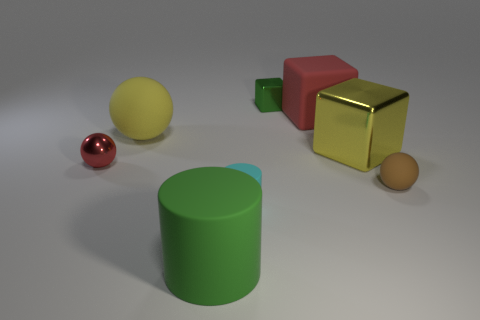Add 2 red things. How many objects exist? 10 Subtract all blocks. How many objects are left? 5 Add 2 small brown rubber things. How many small brown rubber things are left? 3 Add 7 large green metal balls. How many large green metal balls exist? 7 Subtract 1 green cylinders. How many objects are left? 7 Subtract all yellow cubes. Subtract all tiny matte balls. How many objects are left? 6 